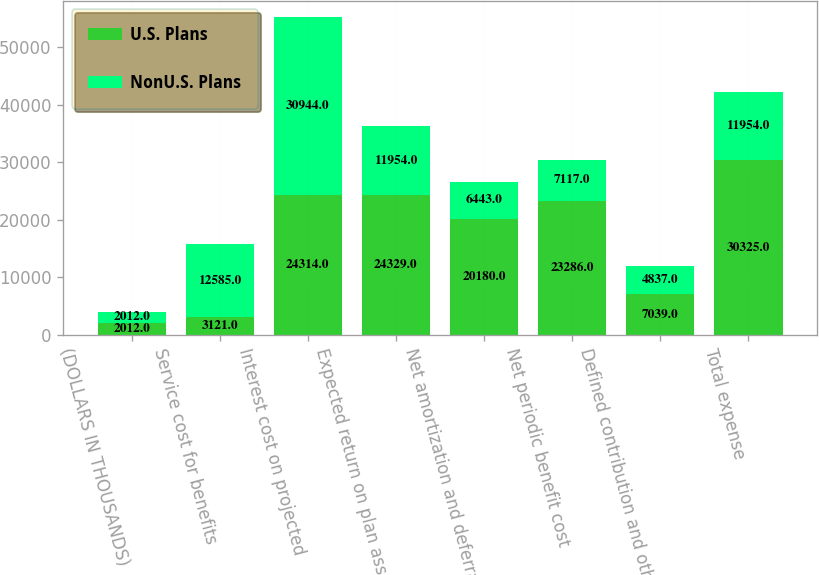Convert chart. <chart><loc_0><loc_0><loc_500><loc_500><stacked_bar_chart><ecel><fcel>(DOLLARS IN THOUSANDS)<fcel>Service cost for benefits<fcel>Interest cost on projected<fcel>Expected return on plan assets<fcel>Net amortization and deferrals<fcel>Net periodic benefit cost<fcel>Defined contribution and other<fcel>Total expense<nl><fcel>U.S. Plans<fcel>2012<fcel>3121<fcel>24314<fcel>24329<fcel>20180<fcel>23286<fcel>7039<fcel>30325<nl><fcel>NonU.S. Plans<fcel>2012<fcel>12585<fcel>30944<fcel>11954<fcel>6443<fcel>7117<fcel>4837<fcel>11954<nl></chart> 